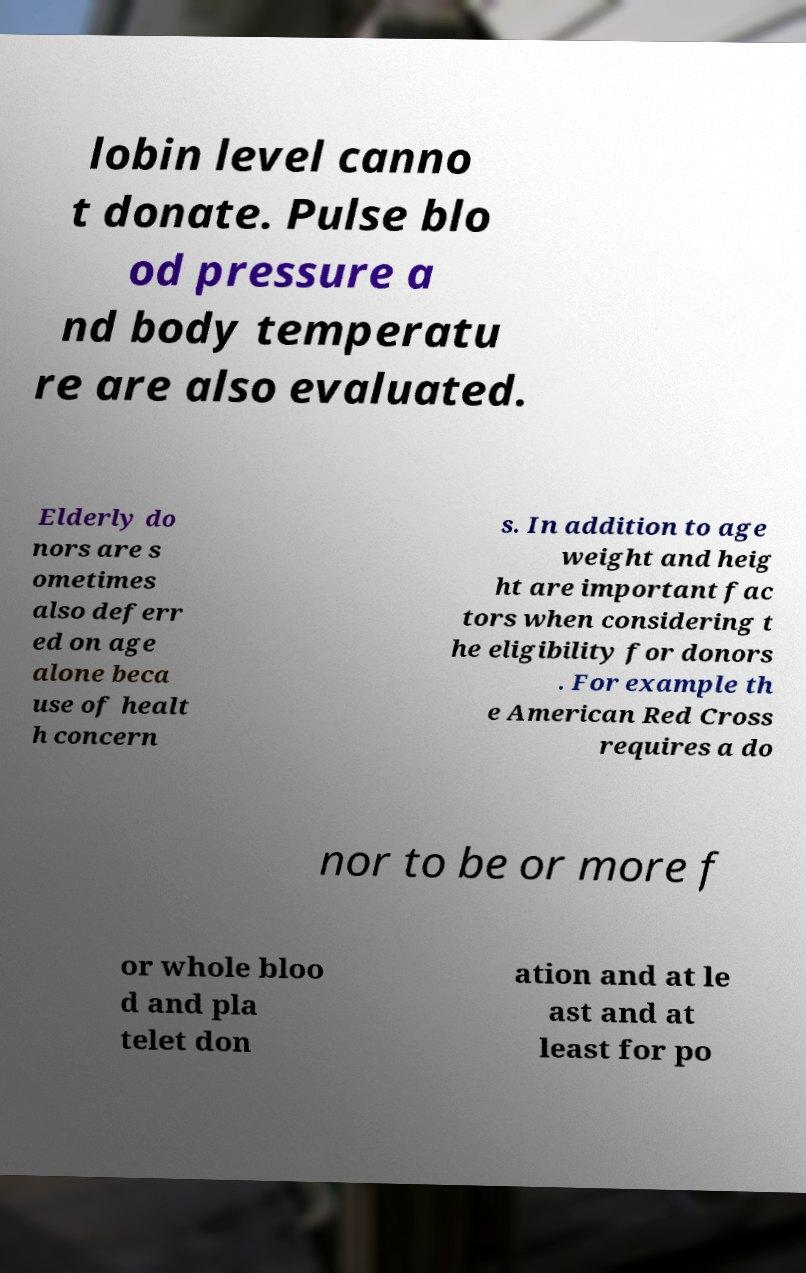Please read and relay the text visible in this image. What does it say? lobin level canno t donate. Pulse blo od pressure a nd body temperatu re are also evaluated. Elderly do nors are s ometimes also deferr ed on age alone beca use of healt h concern s. In addition to age weight and heig ht are important fac tors when considering t he eligibility for donors . For example th e American Red Cross requires a do nor to be or more f or whole bloo d and pla telet don ation and at le ast and at least for po 